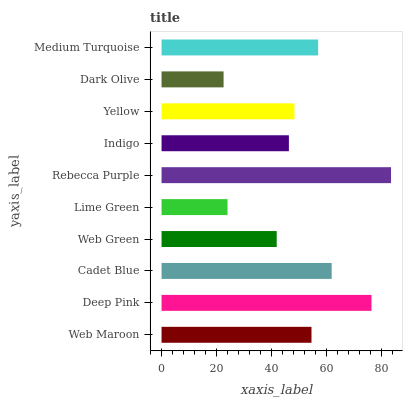Is Dark Olive the minimum?
Answer yes or no. Yes. Is Rebecca Purple the maximum?
Answer yes or no. Yes. Is Deep Pink the minimum?
Answer yes or no. No. Is Deep Pink the maximum?
Answer yes or no. No. Is Deep Pink greater than Web Maroon?
Answer yes or no. Yes. Is Web Maroon less than Deep Pink?
Answer yes or no. Yes. Is Web Maroon greater than Deep Pink?
Answer yes or no. No. Is Deep Pink less than Web Maroon?
Answer yes or no. No. Is Web Maroon the high median?
Answer yes or no. Yes. Is Yellow the low median?
Answer yes or no. Yes. Is Indigo the high median?
Answer yes or no. No. Is Deep Pink the low median?
Answer yes or no. No. 